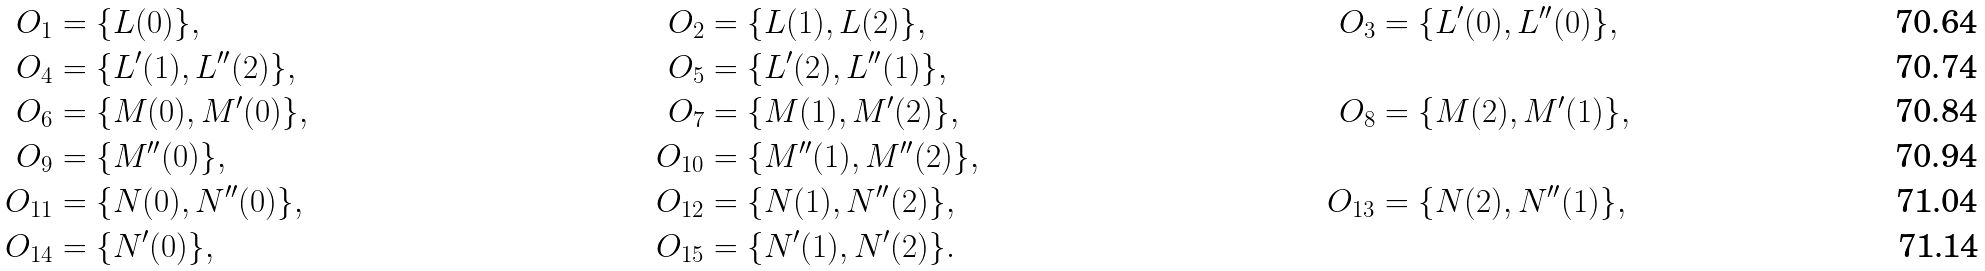Convert formula to latex. <formula><loc_0><loc_0><loc_500><loc_500>O _ { 1 } & = \{ L ( 0 ) \} , & O _ { 2 } & = \{ L ( 1 ) , L ( 2 ) \} , & O _ { 3 } & = \{ L ^ { \prime } ( 0 ) , L ^ { \prime \prime } ( 0 ) \} , \\ O _ { 4 } & = \{ L ^ { \prime } ( 1 ) , L ^ { \prime \prime } ( 2 ) \} , & O _ { 5 } & = \{ L ^ { \prime } ( 2 ) , L ^ { \prime \prime } ( 1 ) \} , \\ O _ { 6 } & = \{ M ( 0 ) , M ^ { \prime } ( 0 ) \} , & O _ { 7 } & = \{ M ( 1 ) , M ^ { \prime } ( 2 ) \} , & O _ { 8 } & = \{ M ( 2 ) , M ^ { \prime } ( 1 ) \} , \\ O _ { 9 } & = \{ M ^ { \prime \prime } ( 0 ) \} , & O _ { 1 0 } & = \{ M ^ { \prime \prime } ( 1 ) , M ^ { \prime \prime } ( 2 ) \} , \\ O _ { 1 1 } & = \{ N ( 0 ) , N ^ { \prime \prime } ( 0 ) \} , & O _ { 1 2 } & = \{ N ( 1 ) , N ^ { \prime \prime } ( 2 ) \} , & O _ { 1 3 } & = \{ N ( 2 ) , N ^ { \prime \prime } ( 1 ) \} , \\ O _ { 1 4 } & = \{ N ^ { \prime } ( 0 ) \} , & O _ { 1 5 } & = \{ N ^ { \prime } ( 1 ) , N ^ { \prime } ( 2 ) \} .</formula> 